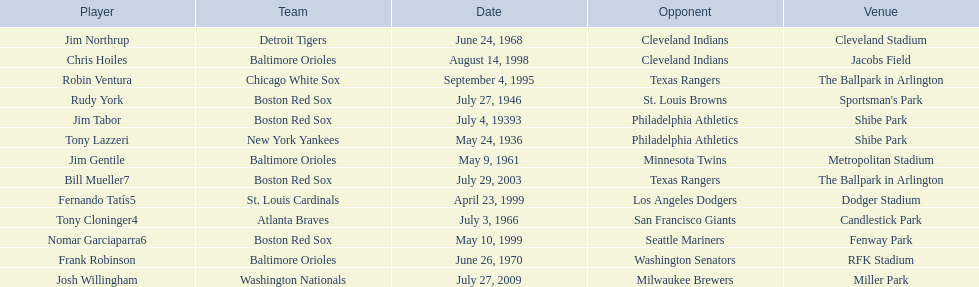What are the dates? May 24, 1936, July 4, 19393, July 27, 1946, May 9, 1961, July 3, 1966, June 24, 1968, June 26, 1970, September 4, 1995, August 14, 1998, April 23, 1999, May 10, 1999, July 29, 2003, July 27, 2009. Which date is in 1936? May 24, 1936. What player is listed for this date? Tony Lazzeri. 